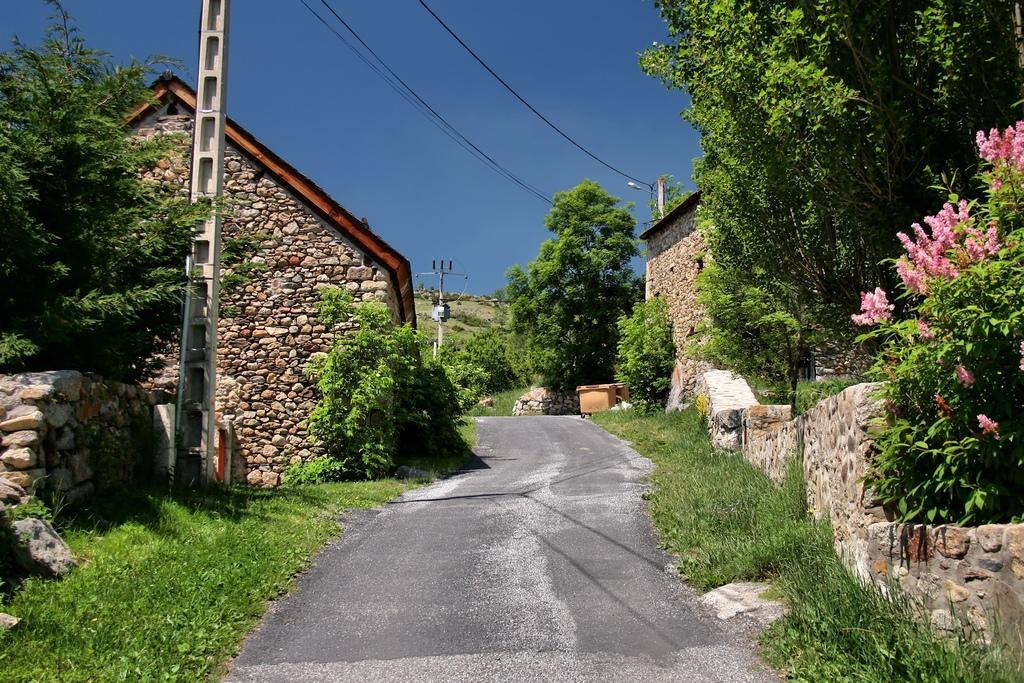How would you summarize this image in a sentence or two? In this image, at the middle there is a road, at the left side there is a stone wall and there is a pole, there is a house, at the right side there is a wall and there are some green color trees, at the top there is a sky which is in blue color. 